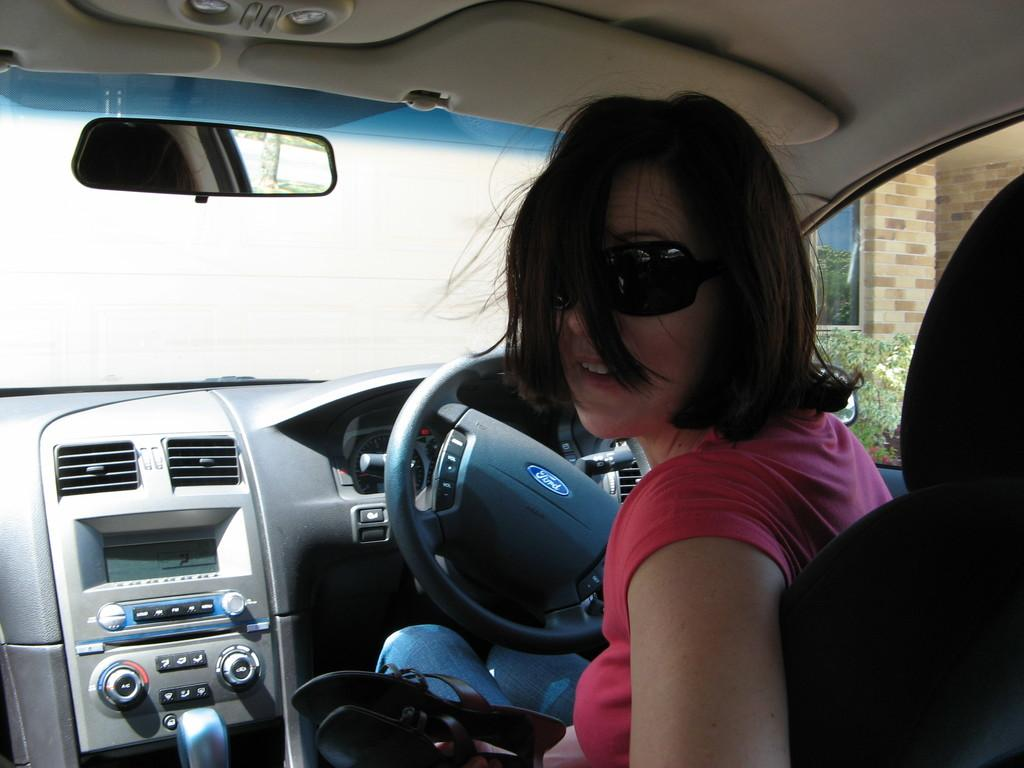Who is the main subject in the image? There is a lady in the image. What is the lady doing in the image? The lady is riding a car. On which side of the image is the car located? The car is on the right side of the image. What is the lady doing with her gaze in the image? The lady is looking behind her in the image. What type of spade is the lady using to dig in the image? There is no spade present in the image; the lady is riding a car. What is the limit of the route the lady is taking in the image? The image does not provide information about the route or its limits. 